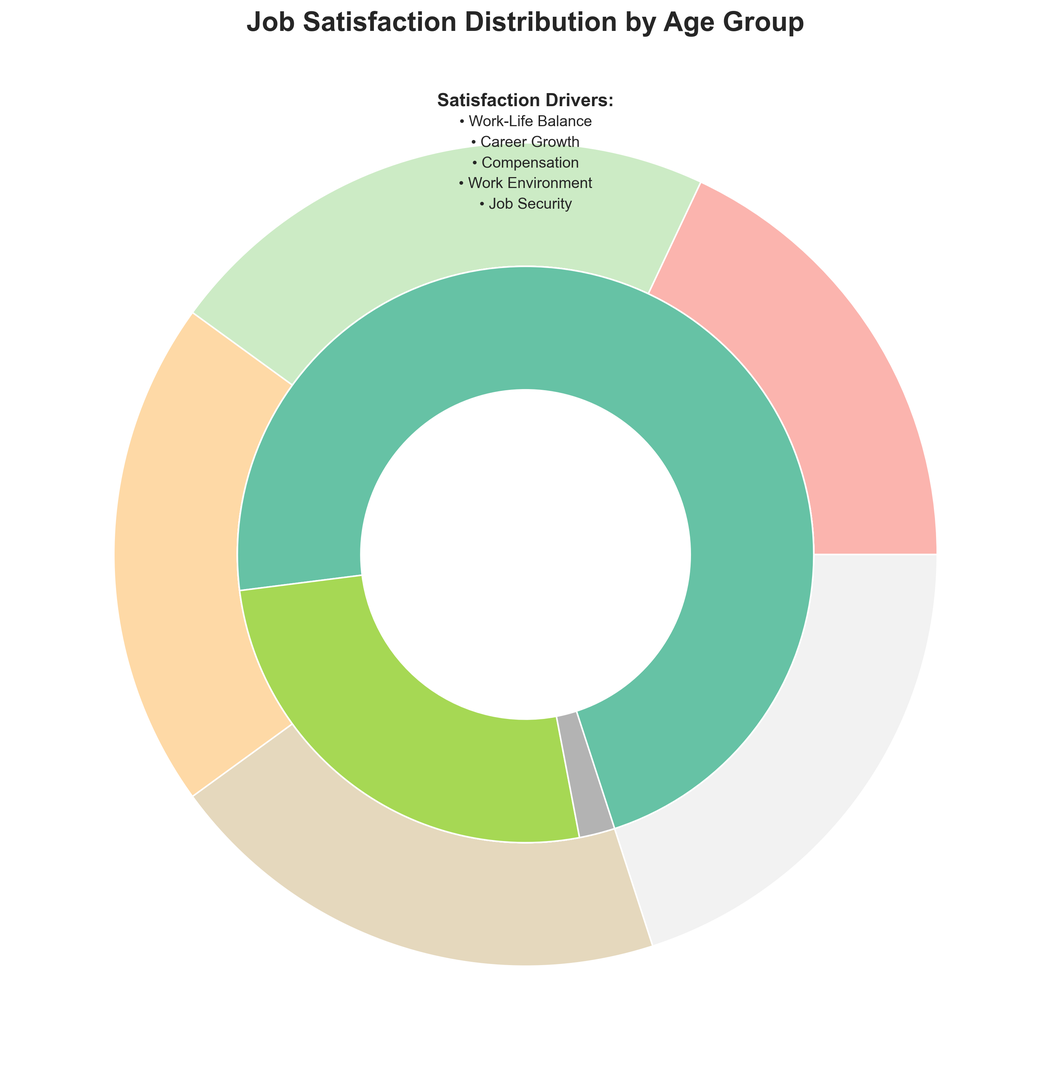Which age group has the highest percentage of high job satisfaction? By looking at the outer ring and focusing on the portion dedicated to "High" satisfaction for each age group, we see that the 56+ age group has the largest section dedicated to "High" satisfaction.
Answer: 56+ Which satisfaction driver has the smallest representation in the 18-25 age group's total job satisfaction? By looking at the inner ring for the 18-25 age group and examining each segment, the segment for "Job Security" is the smallest.
Answer: Job Security For the 26-35 age group, which satisfaction driver contributes the most to medium satisfaction levels? When examining the inner ring for the 26-35 age group, the section representing "Medium" satisfaction shows that "Compensation" is the largest contributor.
Answer: Compensation Compare the representation of "Work-Life Balance" in high satisfaction between the 18-25 and 36-45 age groups. Which group has a higher percentage? By inspecting the inner segments for both age groups and focusing on "Work-Life Balance" under high satisfaction, the 36-45 age group has a slightly larger portion than the 18-25 age group.
Answer: 36-45 What is the combined percentage of high satisfaction driven by "Career Growth" for the 18-25 and 26-35 age groups? The 18-25 group has 12% and the 26-35 group has 18% for "Career Growth" under high satisfaction. Summing them up gives 12 + 18 = 30.
Answer: 30% Which satisfaction driver dominates high satisfaction for the 46-55 age group? By viewing the inner segment related to high satisfaction for the 46-55 age group, the largest portion is dedicated to "Job Security".
Answer: Job Security How does the percentage of medium satisfaction driven by "Work Environment" change from the 36-45 age group to the 56+ age group? For the 36-45 age group, "Work Environment" is 5%. For the 56+ age group, it remains 5%. So, there is no change.
Answer: No change Which age group has the smallest overall job satisfaction percentage represented? By inspecting the outer ring and comparing the total size of each age group's segment, the 18-25 age group has the smallest overall satisfaction percentage.
Answer: 18-25 How much larger is the high satisfaction percentage driven by "Compensation" in the 46-55 age group compared to the 36-45 age group? The 46-55 age group has 15% for high "Compensation," and the 36-45 age group has 14%. So, the difference is 15 - 14 = 1%.
Answer: 1% What is the visual distinction between high and medium satisfaction levels in the inner ring for the 26-35 age group? By observing the inner ring for the 26-35 age group, the high satisfaction levels are represented by wider segments (Career Growth and Work-Life Balance) as opposed to the medium satisfaction levels which have narrower segments (Compensation and Work Environment).
Answer: Wider segments for high satisfaction 